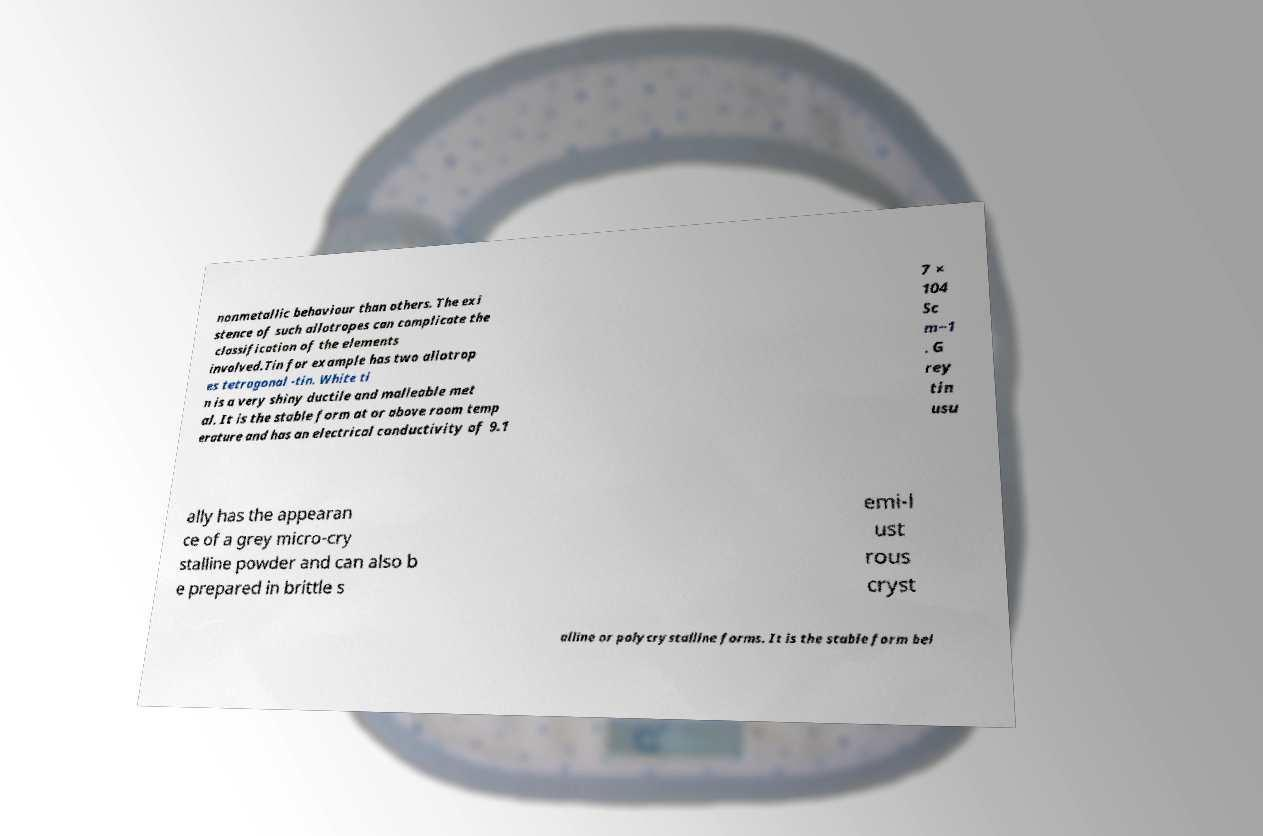Could you assist in decoding the text presented in this image and type it out clearly? nonmetallic behaviour than others. The exi stence of such allotropes can complicate the classification of the elements involved.Tin for example has two allotrop es tetragonal -tin. White ti n is a very shiny ductile and malleable met al. It is the stable form at or above room temp erature and has an electrical conductivity of 9.1 7 × 104 Sc m−1 . G rey tin usu ally has the appearan ce of a grey micro-cry stalline powder and can also b e prepared in brittle s emi-l ust rous cryst alline or polycrystalline forms. It is the stable form bel 